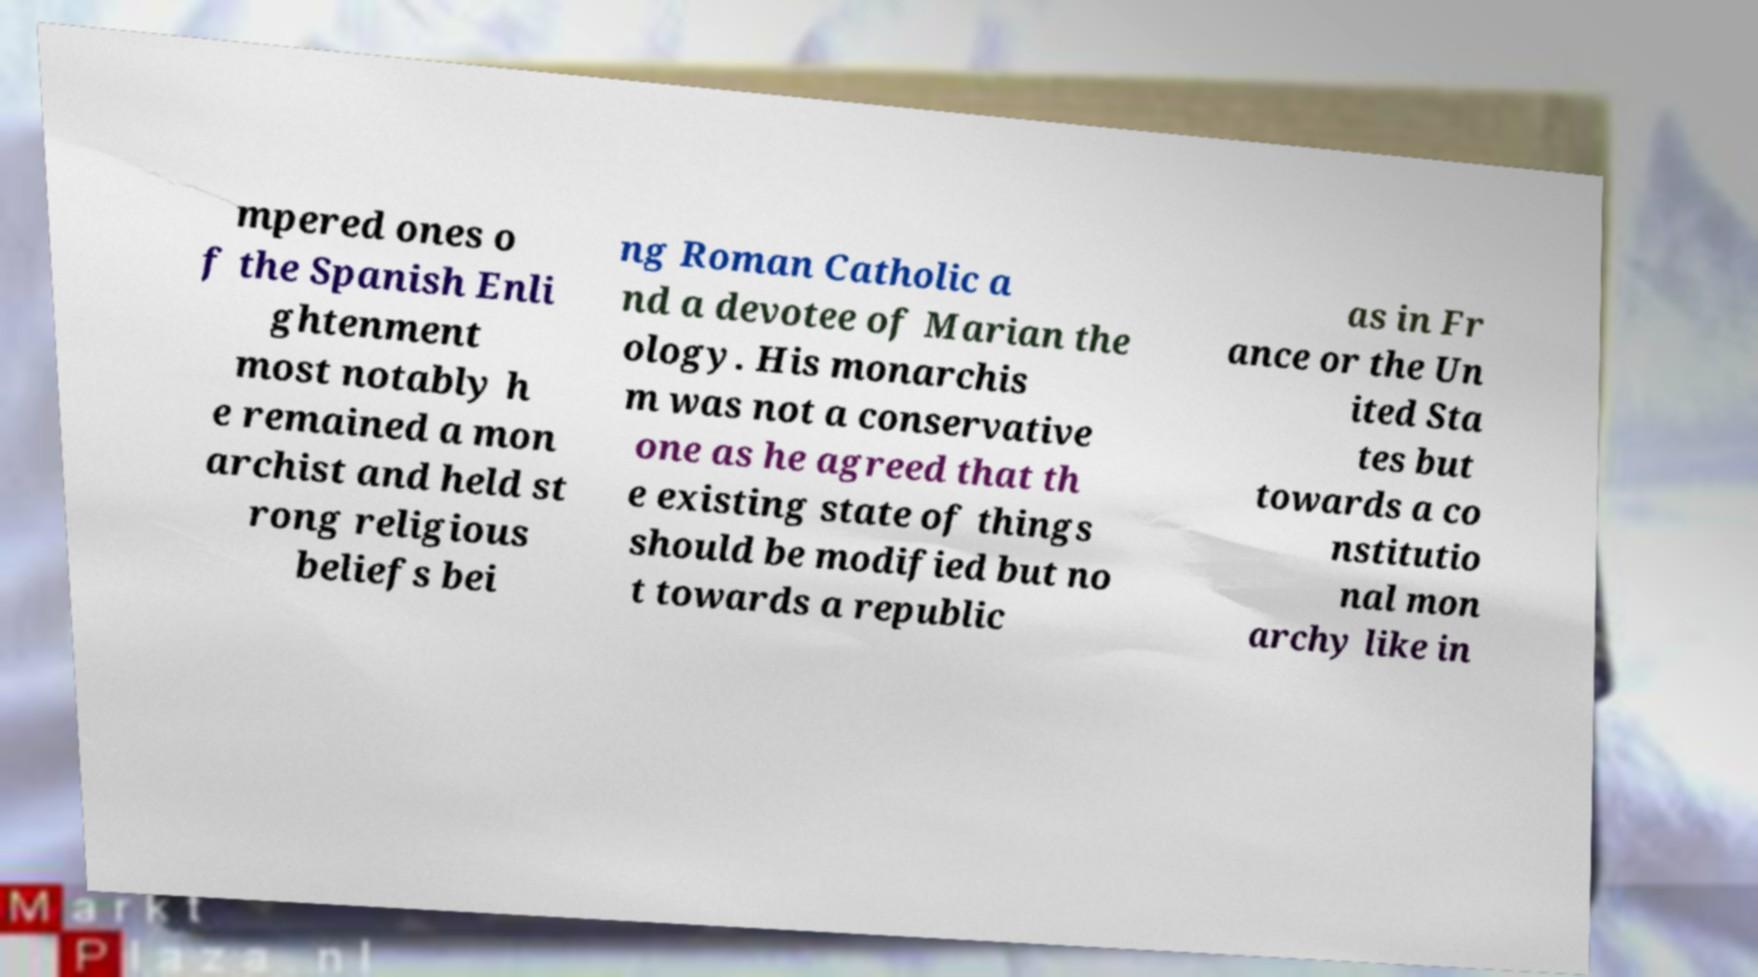What messages or text are displayed in this image? I need them in a readable, typed format. mpered ones o f the Spanish Enli ghtenment most notably h e remained a mon archist and held st rong religious beliefs bei ng Roman Catholic a nd a devotee of Marian the ology. His monarchis m was not a conservative one as he agreed that th e existing state of things should be modified but no t towards a republic as in Fr ance or the Un ited Sta tes but towards a co nstitutio nal mon archy like in 